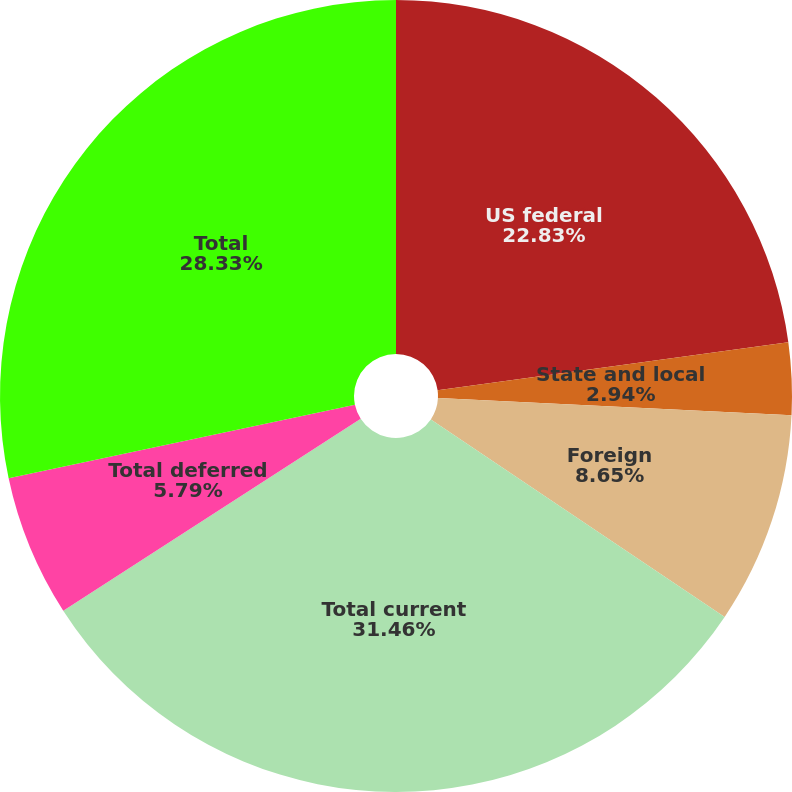Convert chart. <chart><loc_0><loc_0><loc_500><loc_500><pie_chart><fcel>US federal<fcel>State and local<fcel>Foreign<fcel>Total current<fcel>Total deferred<fcel>Total<nl><fcel>22.83%<fcel>2.94%<fcel>8.65%<fcel>31.46%<fcel>5.79%<fcel>28.33%<nl></chart> 